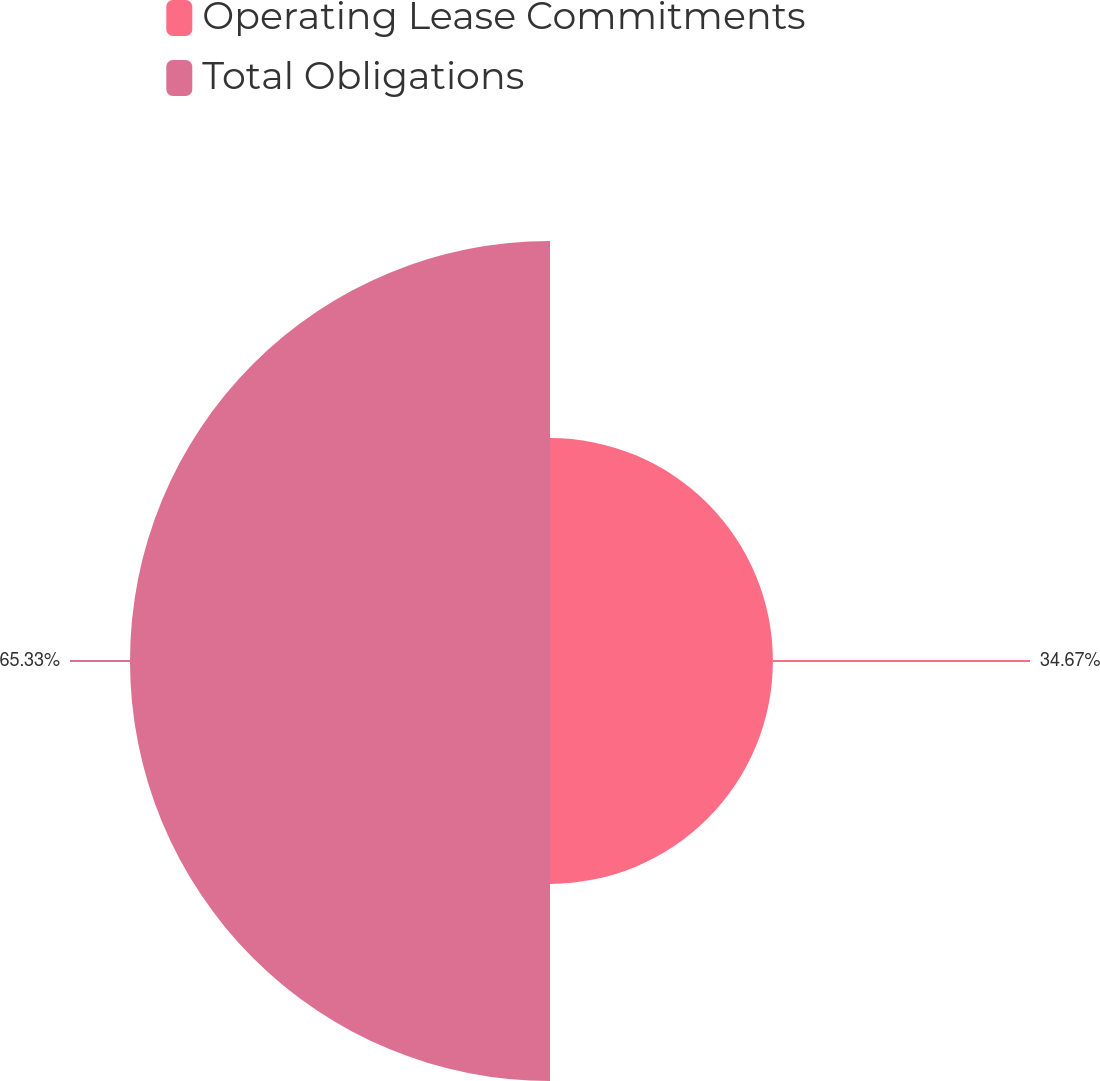Convert chart to OTSL. <chart><loc_0><loc_0><loc_500><loc_500><pie_chart><fcel>Operating Lease Commitments<fcel>Total Obligations<nl><fcel>34.67%<fcel>65.33%<nl></chart> 